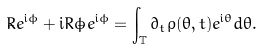Convert formula to latex. <formula><loc_0><loc_0><loc_500><loc_500>{ \dot { R } } e ^ { { \mathrm i } \phi } + { \mathrm i } R \dot { \phi } e ^ { { \mathrm i } \phi } = \int _ { \mathbb { T } } \partial _ { t } \rho ( \theta , t ) e ^ { { \mathrm i } \theta } d \theta .</formula> 